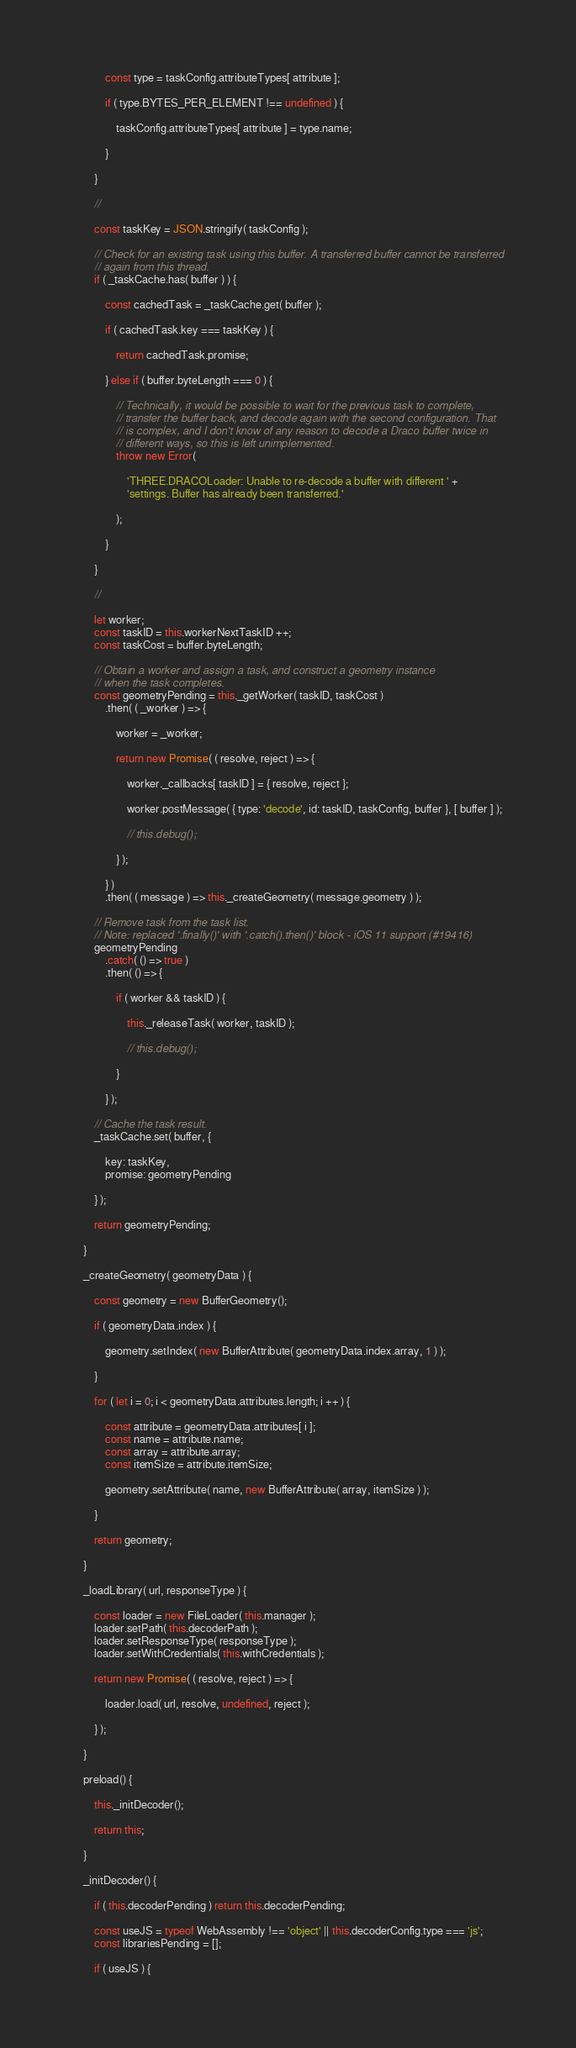<code> <loc_0><loc_0><loc_500><loc_500><_JavaScript_>
			const type = taskConfig.attributeTypes[ attribute ];

			if ( type.BYTES_PER_ELEMENT !== undefined ) {

				taskConfig.attributeTypes[ attribute ] = type.name;

			}

		}

		//

		const taskKey = JSON.stringify( taskConfig );

		// Check for an existing task using this buffer. A transferred buffer cannot be transferred
		// again from this thread.
		if ( _taskCache.has( buffer ) ) {

			const cachedTask = _taskCache.get( buffer );

			if ( cachedTask.key === taskKey ) {

				return cachedTask.promise;

			} else if ( buffer.byteLength === 0 ) {

				// Technically, it would be possible to wait for the previous task to complete,
				// transfer the buffer back, and decode again with the second configuration. That
				// is complex, and I don't know of any reason to decode a Draco buffer twice in
				// different ways, so this is left unimplemented.
				throw new Error(

					'THREE.DRACOLoader: Unable to re-decode a buffer with different ' +
					'settings. Buffer has already been transferred.'

				);

			}

		}

		//

		let worker;
		const taskID = this.workerNextTaskID ++;
		const taskCost = buffer.byteLength;

		// Obtain a worker and assign a task, and construct a geometry instance
		// when the task completes.
		const geometryPending = this._getWorker( taskID, taskCost )
			.then( ( _worker ) => {

				worker = _worker;

				return new Promise( ( resolve, reject ) => {

					worker._callbacks[ taskID ] = { resolve, reject };

					worker.postMessage( { type: 'decode', id: taskID, taskConfig, buffer }, [ buffer ] );

					// this.debug();

				} );

			} )
			.then( ( message ) => this._createGeometry( message.geometry ) );

		// Remove task from the task list.
		// Note: replaced '.finally()' with '.catch().then()' block - iOS 11 support (#19416)
		geometryPending
			.catch( () => true )
			.then( () => {

				if ( worker && taskID ) {

					this._releaseTask( worker, taskID );

					// this.debug();

				}

			} );

		// Cache the task result.
		_taskCache.set( buffer, {

			key: taskKey,
			promise: geometryPending

		} );

		return geometryPending;

	}

	_createGeometry( geometryData ) {

		const geometry = new BufferGeometry();

		if ( geometryData.index ) {

			geometry.setIndex( new BufferAttribute( geometryData.index.array, 1 ) );

		}

		for ( let i = 0; i < geometryData.attributes.length; i ++ ) {

			const attribute = geometryData.attributes[ i ];
			const name = attribute.name;
			const array = attribute.array;
			const itemSize = attribute.itemSize;

			geometry.setAttribute( name, new BufferAttribute( array, itemSize ) );

		}

		return geometry;

	}

	_loadLibrary( url, responseType ) {

		const loader = new FileLoader( this.manager );
		loader.setPath( this.decoderPath );
		loader.setResponseType( responseType );
		loader.setWithCredentials( this.withCredentials );

		return new Promise( ( resolve, reject ) => {

			loader.load( url, resolve, undefined, reject );

		} );

	}

	preload() {

		this._initDecoder();

		return this;

	}

	_initDecoder() {

		if ( this.decoderPending ) return this.decoderPending;

		const useJS = typeof WebAssembly !== 'object' || this.decoderConfig.type === 'js';
		const librariesPending = [];

		if ( useJS ) {
</code> 